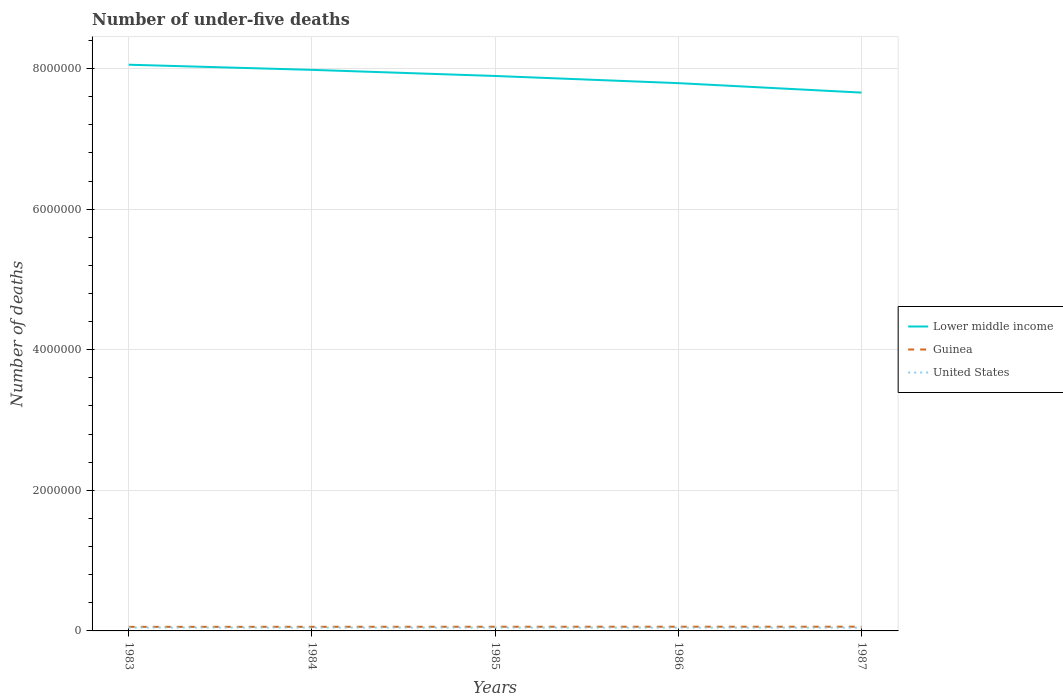How many different coloured lines are there?
Your answer should be very brief. 3. Is the number of lines equal to the number of legend labels?
Offer a terse response. Yes. Across all years, what is the maximum number of under-five deaths in United States?
Offer a terse response. 4.63e+04. In which year was the number of under-five deaths in Lower middle income maximum?
Ensure brevity in your answer.  1987. What is the total number of under-five deaths in United States in the graph?
Keep it short and to the point. 1756. What is the difference between the highest and the second highest number of under-five deaths in Guinea?
Provide a short and direct response. 2035. What is the difference between the highest and the lowest number of under-five deaths in Guinea?
Keep it short and to the point. 3. Is the number of under-five deaths in Lower middle income strictly greater than the number of under-five deaths in United States over the years?
Your answer should be compact. No. How many lines are there?
Provide a succinct answer. 3. How many years are there in the graph?
Keep it short and to the point. 5. Does the graph contain grids?
Provide a short and direct response. Yes. How many legend labels are there?
Offer a terse response. 3. What is the title of the graph?
Your answer should be compact. Number of under-five deaths. What is the label or title of the X-axis?
Offer a very short reply. Years. What is the label or title of the Y-axis?
Provide a succinct answer. Number of deaths. What is the Number of deaths of Lower middle income in 1983?
Give a very brief answer. 8.05e+06. What is the Number of deaths of Guinea in 1983?
Provide a short and direct response. 5.79e+04. What is the Number of deaths in United States in 1983?
Offer a very short reply. 4.84e+04. What is the Number of deaths in Lower middle income in 1984?
Your answer should be very brief. 7.98e+06. What is the Number of deaths in Guinea in 1984?
Provide a short and direct response. 5.85e+04. What is the Number of deaths of United States in 1984?
Make the answer very short. 4.77e+04. What is the Number of deaths in Lower middle income in 1985?
Your answer should be compact. 7.89e+06. What is the Number of deaths in Guinea in 1985?
Your response must be concise. 5.93e+04. What is the Number of deaths in United States in 1985?
Your response must be concise. 4.73e+04. What is the Number of deaths in Lower middle income in 1986?
Ensure brevity in your answer.  7.79e+06. What is the Number of deaths in Guinea in 1986?
Make the answer very short. 5.97e+04. What is the Number of deaths in United States in 1986?
Provide a succinct answer. 4.67e+04. What is the Number of deaths in Lower middle income in 1987?
Give a very brief answer. 7.66e+06. What is the Number of deaths in Guinea in 1987?
Keep it short and to the point. 5.99e+04. What is the Number of deaths of United States in 1987?
Make the answer very short. 4.63e+04. Across all years, what is the maximum Number of deaths in Lower middle income?
Your response must be concise. 8.05e+06. Across all years, what is the maximum Number of deaths in Guinea?
Offer a terse response. 5.99e+04. Across all years, what is the maximum Number of deaths in United States?
Your response must be concise. 4.84e+04. Across all years, what is the minimum Number of deaths of Lower middle income?
Your answer should be very brief. 7.66e+06. Across all years, what is the minimum Number of deaths in Guinea?
Your answer should be very brief. 5.79e+04. Across all years, what is the minimum Number of deaths of United States?
Offer a very short reply. 4.63e+04. What is the total Number of deaths of Lower middle income in the graph?
Your answer should be very brief. 3.94e+07. What is the total Number of deaths in Guinea in the graph?
Provide a short and direct response. 2.95e+05. What is the total Number of deaths in United States in the graph?
Provide a succinct answer. 2.36e+05. What is the difference between the Number of deaths in Lower middle income in 1983 and that in 1984?
Keep it short and to the point. 7.32e+04. What is the difference between the Number of deaths of Guinea in 1983 and that in 1984?
Ensure brevity in your answer.  -601. What is the difference between the Number of deaths in United States in 1983 and that in 1984?
Your answer should be compact. 680. What is the difference between the Number of deaths in Lower middle income in 1983 and that in 1985?
Provide a short and direct response. 1.60e+05. What is the difference between the Number of deaths of Guinea in 1983 and that in 1985?
Give a very brief answer. -1392. What is the difference between the Number of deaths in United States in 1983 and that in 1985?
Your response must be concise. 1162. What is the difference between the Number of deaths in Lower middle income in 1983 and that in 1986?
Your response must be concise. 2.62e+05. What is the difference between the Number of deaths of Guinea in 1983 and that in 1986?
Keep it short and to the point. -1806. What is the difference between the Number of deaths in United States in 1983 and that in 1986?
Make the answer very short. 1756. What is the difference between the Number of deaths of Lower middle income in 1983 and that in 1987?
Your response must be concise. 3.97e+05. What is the difference between the Number of deaths in Guinea in 1983 and that in 1987?
Your answer should be very brief. -2035. What is the difference between the Number of deaths in United States in 1983 and that in 1987?
Your answer should be very brief. 2165. What is the difference between the Number of deaths of Lower middle income in 1984 and that in 1985?
Make the answer very short. 8.68e+04. What is the difference between the Number of deaths in Guinea in 1984 and that in 1985?
Your response must be concise. -791. What is the difference between the Number of deaths in United States in 1984 and that in 1985?
Your answer should be very brief. 482. What is the difference between the Number of deaths in Lower middle income in 1984 and that in 1986?
Your response must be concise. 1.89e+05. What is the difference between the Number of deaths of Guinea in 1984 and that in 1986?
Give a very brief answer. -1205. What is the difference between the Number of deaths in United States in 1984 and that in 1986?
Provide a short and direct response. 1076. What is the difference between the Number of deaths in Lower middle income in 1984 and that in 1987?
Offer a terse response. 3.23e+05. What is the difference between the Number of deaths of Guinea in 1984 and that in 1987?
Offer a terse response. -1434. What is the difference between the Number of deaths in United States in 1984 and that in 1987?
Your response must be concise. 1485. What is the difference between the Number of deaths in Lower middle income in 1985 and that in 1986?
Keep it short and to the point. 1.02e+05. What is the difference between the Number of deaths in Guinea in 1985 and that in 1986?
Offer a very short reply. -414. What is the difference between the Number of deaths of United States in 1985 and that in 1986?
Keep it short and to the point. 594. What is the difference between the Number of deaths in Lower middle income in 1985 and that in 1987?
Your answer should be very brief. 2.37e+05. What is the difference between the Number of deaths in Guinea in 1985 and that in 1987?
Your answer should be compact. -643. What is the difference between the Number of deaths of United States in 1985 and that in 1987?
Keep it short and to the point. 1003. What is the difference between the Number of deaths of Lower middle income in 1986 and that in 1987?
Give a very brief answer. 1.34e+05. What is the difference between the Number of deaths in Guinea in 1986 and that in 1987?
Offer a very short reply. -229. What is the difference between the Number of deaths in United States in 1986 and that in 1987?
Provide a short and direct response. 409. What is the difference between the Number of deaths in Lower middle income in 1983 and the Number of deaths in Guinea in 1984?
Make the answer very short. 8.00e+06. What is the difference between the Number of deaths of Lower middle income in 1983 and the Number of deaths of United States in 1984?
Your answer should be very brief. 8.01e+06. What is the difference between the Number of deaths of Guinea in 1983 and the Number of deaths of United States in 1984?
Provide a succinct answer. 1.01e+04. What is the difference between the Number of deaths in Lower middle income in 1983 and the Number of deaths in Guinea in 1985?
Give a very brief answer. 8.00e+06. What is the difference between the Number of deaths in Lower middle income in 1983 and the Number of deaths in United States in 1985?
Offer a terse response. 8.01e+06. What is the difference between the Number of deaths of Guinea in 1983 and the Number of deaths of United States in 1985?
Provide a succinct answer. 1.06e+04. What is the difference between the Number of deaths of Lower middle income in 1983 and the Number of deaths of Guinea in 1986?
Give a very brief answer. 7.99e+06. What is the difference between the Number of deaths in Lower middle income in 1983 and the Number of deaths in United States in 1986?
Provide a short and direct response. 8.01e+06. What is the difference between the Number of deaths in Guinea in 1983 and the Number of deaths in United States in 1986?
Keep it short and to the point. 1.12e+04. What is the difference between the Number of deaths in Lower middle income in 1983 and the Number of deaths in Guinea in 1987?
Your response must be concise. 7.99e+06. What is the difference between the Number of deaths of Lower middle income in 1983 and the Number of deaths of United States in 1987?
Provide a succinct answer. 8.01e+06. What is the difference between the Number of deaths of Guinea in 1983 and the Number of deaths of United States in 1987?
Offer a very short reply. 1.16e+04. What is the difference between the Number of deaths of Lower middle income in 1984 and the Number of deaths of Guinea in 1985?
Ensure brevity in your answer.  7.92e+06. What is the difference between the Number of deaths in Lower middle income in 1984 and the Number of deaths in United States in 1985?
Make the answer very short. 7.93e+06. What is the difference between the Number of deaths in Guinea in 1984 and the Number of deaths in United States in 1985?
Offer a terse response. 1.12e+04. What is the difference between the Number of deaths in Lower middle income in 1984 and the Number of deaths in Guinea in 1986?
Ensure brevity in your answer.  7.92e+06. What is the difference between the Number of deaths in Lower middle income in 1984 and the Number of deaths in United States in 1986?
Provide a succinct answer. 7.93e+06. What is the difference between the Number of deaths of Guinea in 1984 and the Number of deaths of United States in 1986?
Your answer should be compact. 1.18e+04. What is the difference between the Number of deaths in Lower middle income in 1984 and the Number of deaths in Guinea in 1987?
Your answer should be very brief. 7.92e+06. What is the difference between the Number of deaths of Lower middle income in 1984 and the Number of deaths of United States in 1987?
Ensure brevity in your answer.  7.93e+06. What is the difference between the Number of deaths of Guinea in 1984 and the Number of deaths of United States in 1987?
Make the answer very short. 1.22e+04. What is the difference between the Number of deaths in Lower middle income in 1985 and the Number of deaths in Guinea in 1986?
Offer a very short reply. 7.83e+06. What is the difference between the Number of deaths in Lower middle income in 1985 and the Number of deaths in United States in 1986?
Your response must be concise. 7.85e+06. What is the difference between the Number of deaths of Guinea in 1985 and the Number of deaths of United States in 1986?
Provide a short and direct response. 1.26e+04. What is the difference between the Number of deaths of Lower middle income in 1985 and the Number of deaths of Guinea in 1987?
Ensure brevity in your answer.  7.83e+06. What is the difference between the Number of deaths in Lower middle income in 1985 and the Number of deaths in United States in 1987?
Provide a succinct answer. 7.85e+06. What is the difference between the Number of deaths in Guinea in 1985 and the Number of deaths in United States in 1987?
Provide a succinct answer. 1.30e+04. What is the difference between the Number of deaths in Lower middle income in 1986 and the Number of deaths in Guinea in 1987?
Give a very brief answer. 7.73e+06. What is the difference between the Number of deaths of Lower middle income in 1986 and the Number of deaths of United States in 1987?
Your answer should be very brief. 7.75e+06. What is the difference between the Number of deaths in Guinea in 1986 and the Number of deaths in United States in 1987?
Ensure brevity in your answer.  1.34e+04. What is the average Number of deaths of Lower middle income per year?
Provide a short and direct response. 7.88e+06. What is the average Number of deaths of Guinea per year?
Provide a succinct answer. 5.91e+04. What is the average Number of deaths of United States per year?
Provide a succinct answer. 4.73e+04. In the year 1983, what is the difference between the Number of deaths in Lower middle income and Number of deaths in Guinea?
Make the answer very short. 8.00e+06. In the year 1983, what is the difference between the Number of deaths in Lower middle income and Number of deaths in United States?
Offer a terse response. 8.01e+06. In the year 1983, what is the difference between the Number of deaths in Guinea and Number of deaths in United States?
Make the answer very short. 9459. In the year 1984, what is the difference between the Number of deaths in Lower middle income and Number of deaths in Guinea?
Keep it short and to the point. 7.92e+06. In the year 1984, what is the difference between the Number of deaths of Lower middle income and Number of deaths of United States?
Keep it short and to the point. 7.93e+06. In the year 1984, what is the difference between the Number of deaths of Guinea and Number of deaths of United States?
Your answer should be very brief. 1.07e+04. In the year 1985, what is the difference between the Number of deaths in Lower middle income and Number of deaths in Guinea?
Offer a terse response. 7.84e+06. In the year 1985, what is the difference between the Number of deaths in Lower middle income and Number of deaths in United States?
Keep it short and to the point. 7.85e+06. In the year 1985, what is the difference between the Number of deaths of Guinea and Number of deaths of United States?
Provide a short and direct response. 1.20e+04. In the year 1986, what is the difference between the Number of deaths in Lower middle income and Number of deaths in Guinea?
Offer a terse response. 7.73e+06. In the year 1986, what is the difference between the Number of deaths in Lower middle income and Number of deaths in United States?
Offer a terse response. 7.75e+06. In the year 1986, what is the difference between the Number of deaths of Guinea and Number of deaths of United States?
Keep it short and to the point. 1.30e+04. In the year 1987, what is the difference between the Number of deaths in Lower middle income and Number of deaths in Guinea?
Your answer should be compact. 7.60e+06. In the year 1987, what is the difference between the Number of deaths in Lower middle income and Number of deaths in United States?
Offer a terse response. 7.61e+06. In the year 1987, what is the difference between the Number of deaths in Guinea and Number of deaths in United States?
Your response must be concise. 1.37e+04. What is the ratio of the Number of deaths of Lower middle income in 1983 to that in 1984?
Make the answer very short. 1.01. What is the ratio of the Number of deaths of Guinea in 1983 to that in 1984?
Keep it short and to the point. 0.99. What is the ratio of the Number of deaths of United States in 1983 to that in 1984?
Provide a succinct answer. 1.01. What is the ratio of the Number of deaths in Lower middle income in 1983 to that in 1985?
Your response must be concise. 1.02. What is the ratio of the Number of deaths in Guinea in 1983 to that in 1985?
Keep it short and to the point. 0.98. What is the ratio of the Number of deaths of United States in 1983 to that in 1985?
Your response must be concise. 1.02. What is the ratio of the Number of deaths in Lower middle income in 1983 to that in 1986?
Your response must be concise. 1.03. What is the ratio of the Number of deaths in Guinea in 1983 to that in 1986?
Your answer should be very brief. 0.97. What is the ratio of the Number of deaths of United States in 1983 to that in 1986?
Offer a very short reply. 1.04. What is the ratio of the Number of deaths in Lower middle income in 1983 to that in 1987?
Provide a succinct answer. 1.05. What is the ratio of the Number of deaths in United States in 1983 to that in 1987?
Give a very brief answer. 1.05. What is the ratio of the Number of deaths of Lower middle income in 1984 to that in 1985?
Make the answer very short. 1.01. What is the ratio of the Number of deaths in Guinea in 1984 to that in 1985?
Provide a short and direct response. 0.99. What is the ratio of the Number of deaths in United States in 1984 to that in 1985?
Offer a very short reply. 1.01. What is the ratio of the Number of deaths of Lower middle income in 1984 to that in 1986?
Your response must be concise. 1.02. What is the ratio of the Number of deaths in Guinea in 1984 to that in 1986?
Make the answer very short. 0.98. What is the ratio of the Number of deaths in United States in 1984 to that in 1986?
Give a very brief answer. 1.02. What is the ratio of the Number of deaths of Lower middle income in 1984 to that in 1987?
Your response must be concise. 1.04. What is the ratio of the Number of deaths in Guinea in 1984 to that in 1987?
Provide a succinct answer. 0.98. What is the ratio of the Number of deaths in United States in 1984 to that in 1987?
Your answer should be very brief. 1.03. What is the ratio of the Number of deaths of Lower middle income in 1985 to that in 1986?
Give a very brief answer. 1.01. What is the ratio of the Number of deaths in United States in 1985 to that in 1986?
Keep it short and to the point. 1.01. What is the ratio of the Number of deaths of Lower middle income in 1985 to that in 1987?
Give a very brief answer. 1.03. What is the ratio of the Number of deaths in Guinea in 1985 to that in 1987?
Offer a very short reply. 0.99. What is the ratio of the Number of deaths in United States in 1985 to that in 1987?
Offer a terse response. 1.02. What is the ratio of the Number of deaths of Lower middle income in 1986 to that in 1987?
Offer a terse response. 1.02. What is the ratio of the Number of deaths of United States in 1986 to that in 1987?
Provide a short and direct response. 1.01. What is the difference between the highest and the second highest Number of deaths in Lower middle income?
Your response must be concise. 7.32e+04. What is the difference between the highest and the second highest Number of deaths of Guinea?
Provide a succinct answer. 229. What is the difference between the highest and the second highest Number of deaths of United States?
Make the answer very short. 680. What is the difference between the highest and the lowest Number of deaths in Lower middle income?
Ensure brevity in your answer.  3.97e+05. What is the difference between the highest and the lowest Number of deaths of Guinea?
Make the answer very short. 2035. What is the difference between the highest and the lowest Number of deaths in United States?
Your answer should be very brief. 2165. 